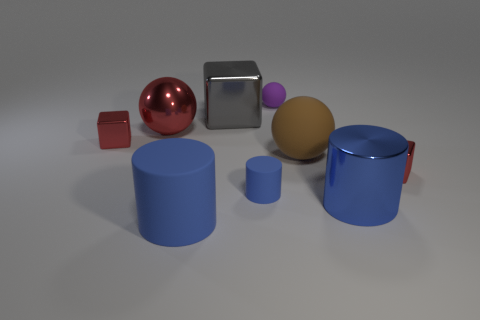Could you guess the purpose of this assembly of objects? This assembly appears to be a staged collection of geometric shapes, possibly for the purpose of a visual demonstration or an artistic composition. It's meant to showcase various colors, materials, and shapes, as well as the effects of light on glossy and matte surfaces. 